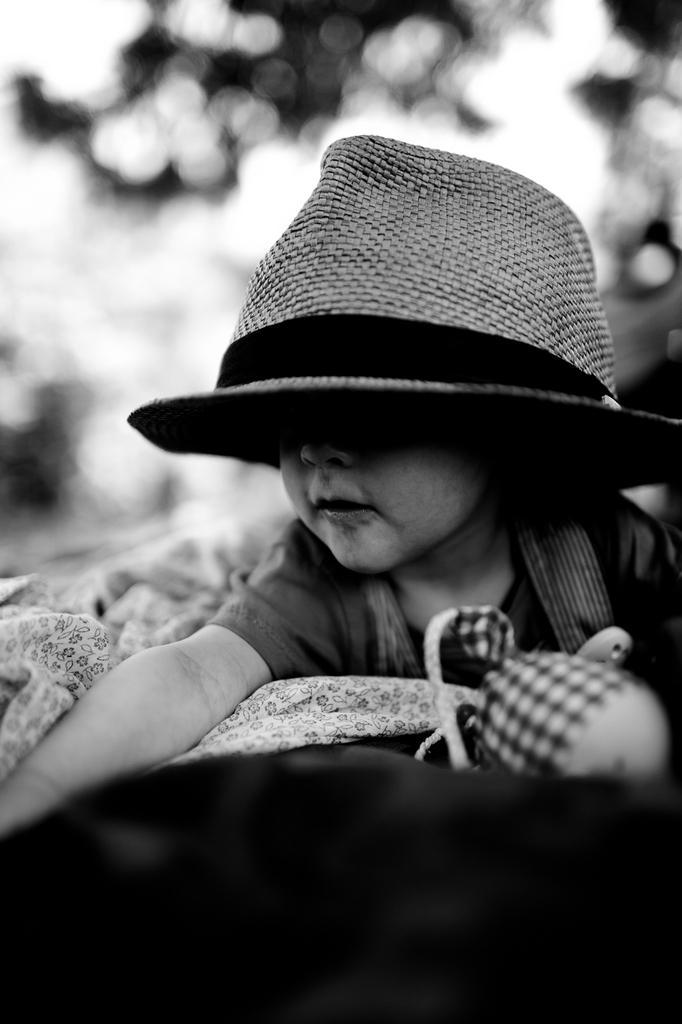Can you describe this image briefly? This is a black and white image. Here I can see a baby is wearing cap. Beside her there is a bed sheet and a toy. At the bottom there is an object which seems to be a bed. The background is blurred. 